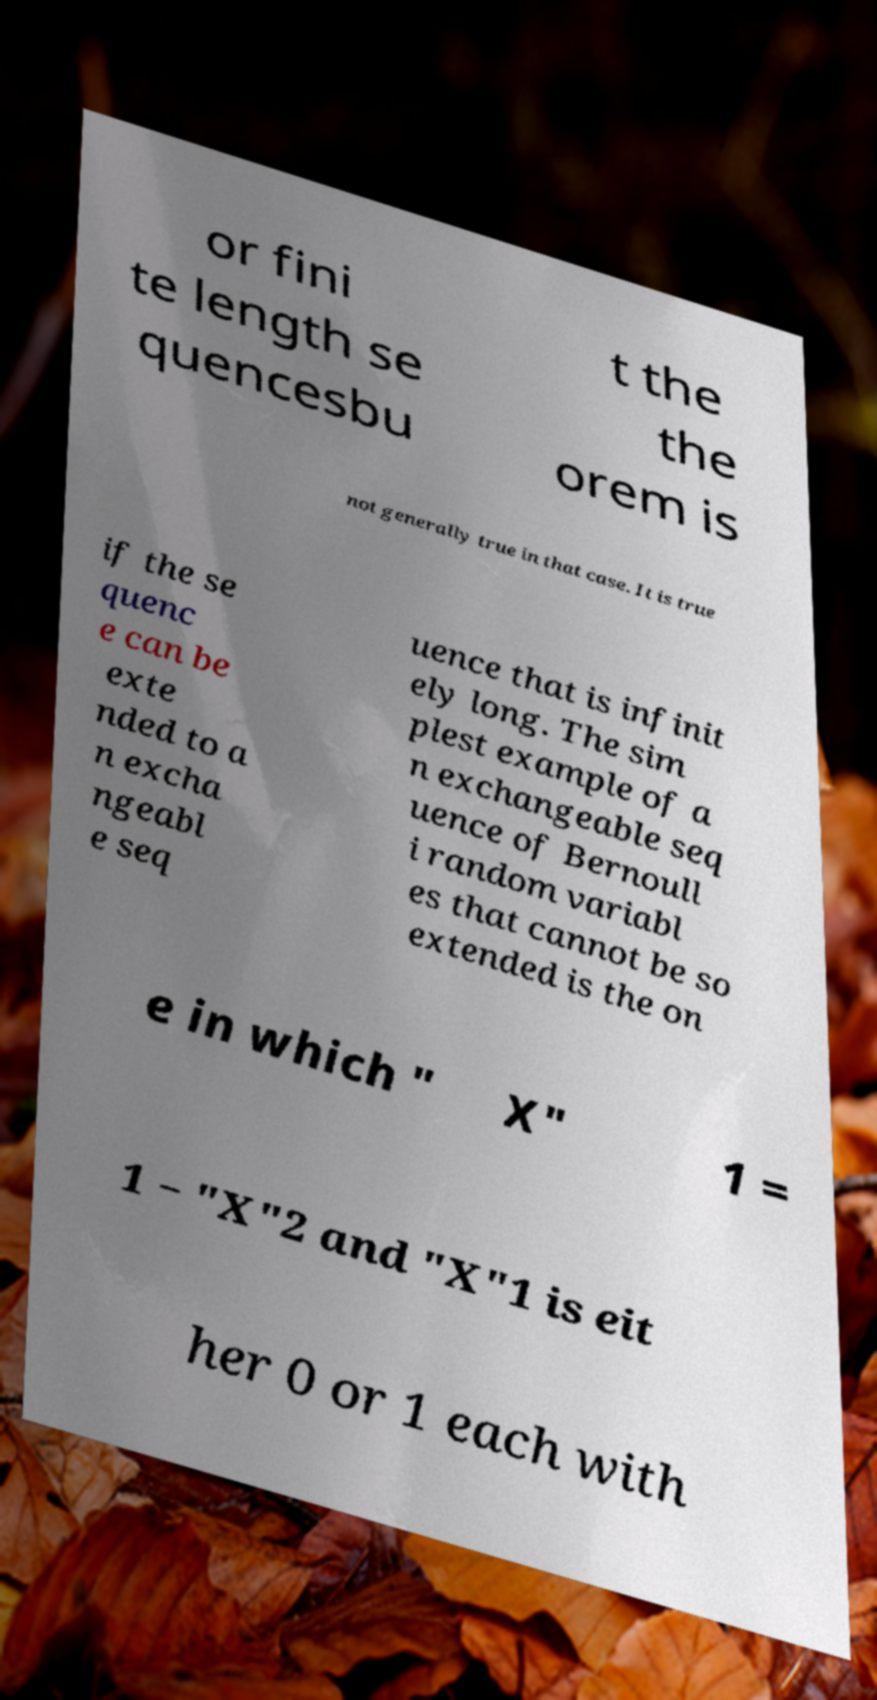Can you accurately transcribe the text from the provided image for me? or fini te length se quencesbu t the the orem is not generally true in that case. It is true if the se quenc e can be exte nded to a n excha ngeabl e seq uence that is infinit ely long. The sim plest example of a n exchangeable seq uence of Bernoull i random variabl es that cannot be so extended is the on e in which " X" 1 = 1 − "X"2 and "X"1 is eit her 0 or 1 each with 